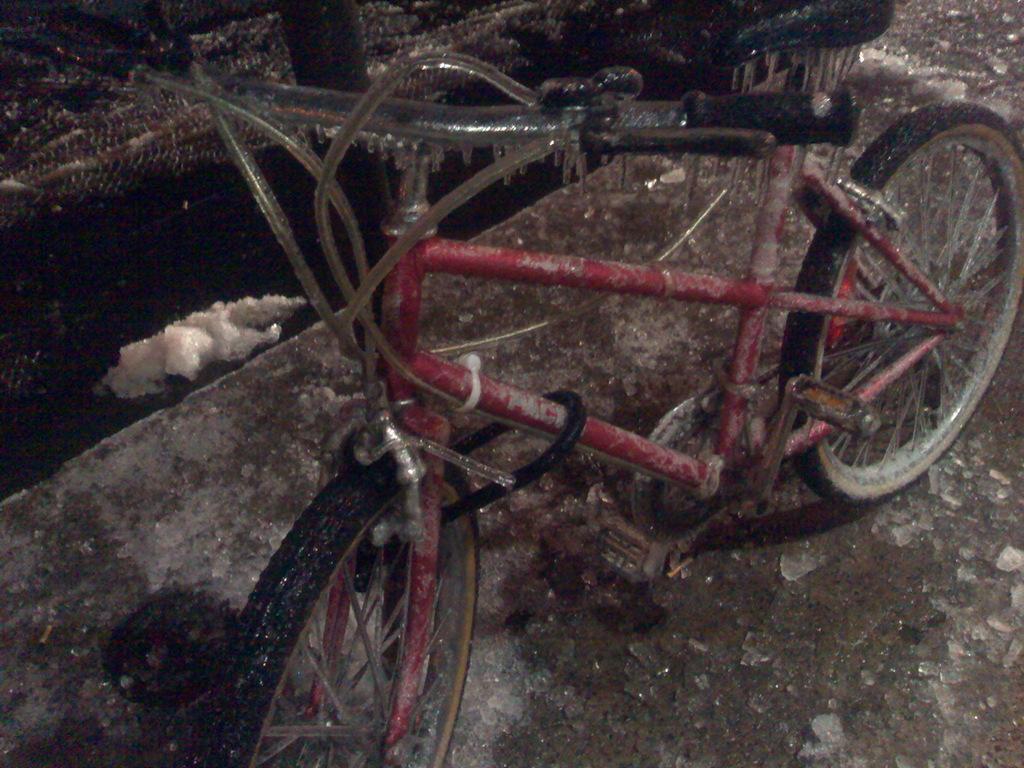Please provide a concise description of this image. This image consist of a bicycle which is in the center on the ground. 